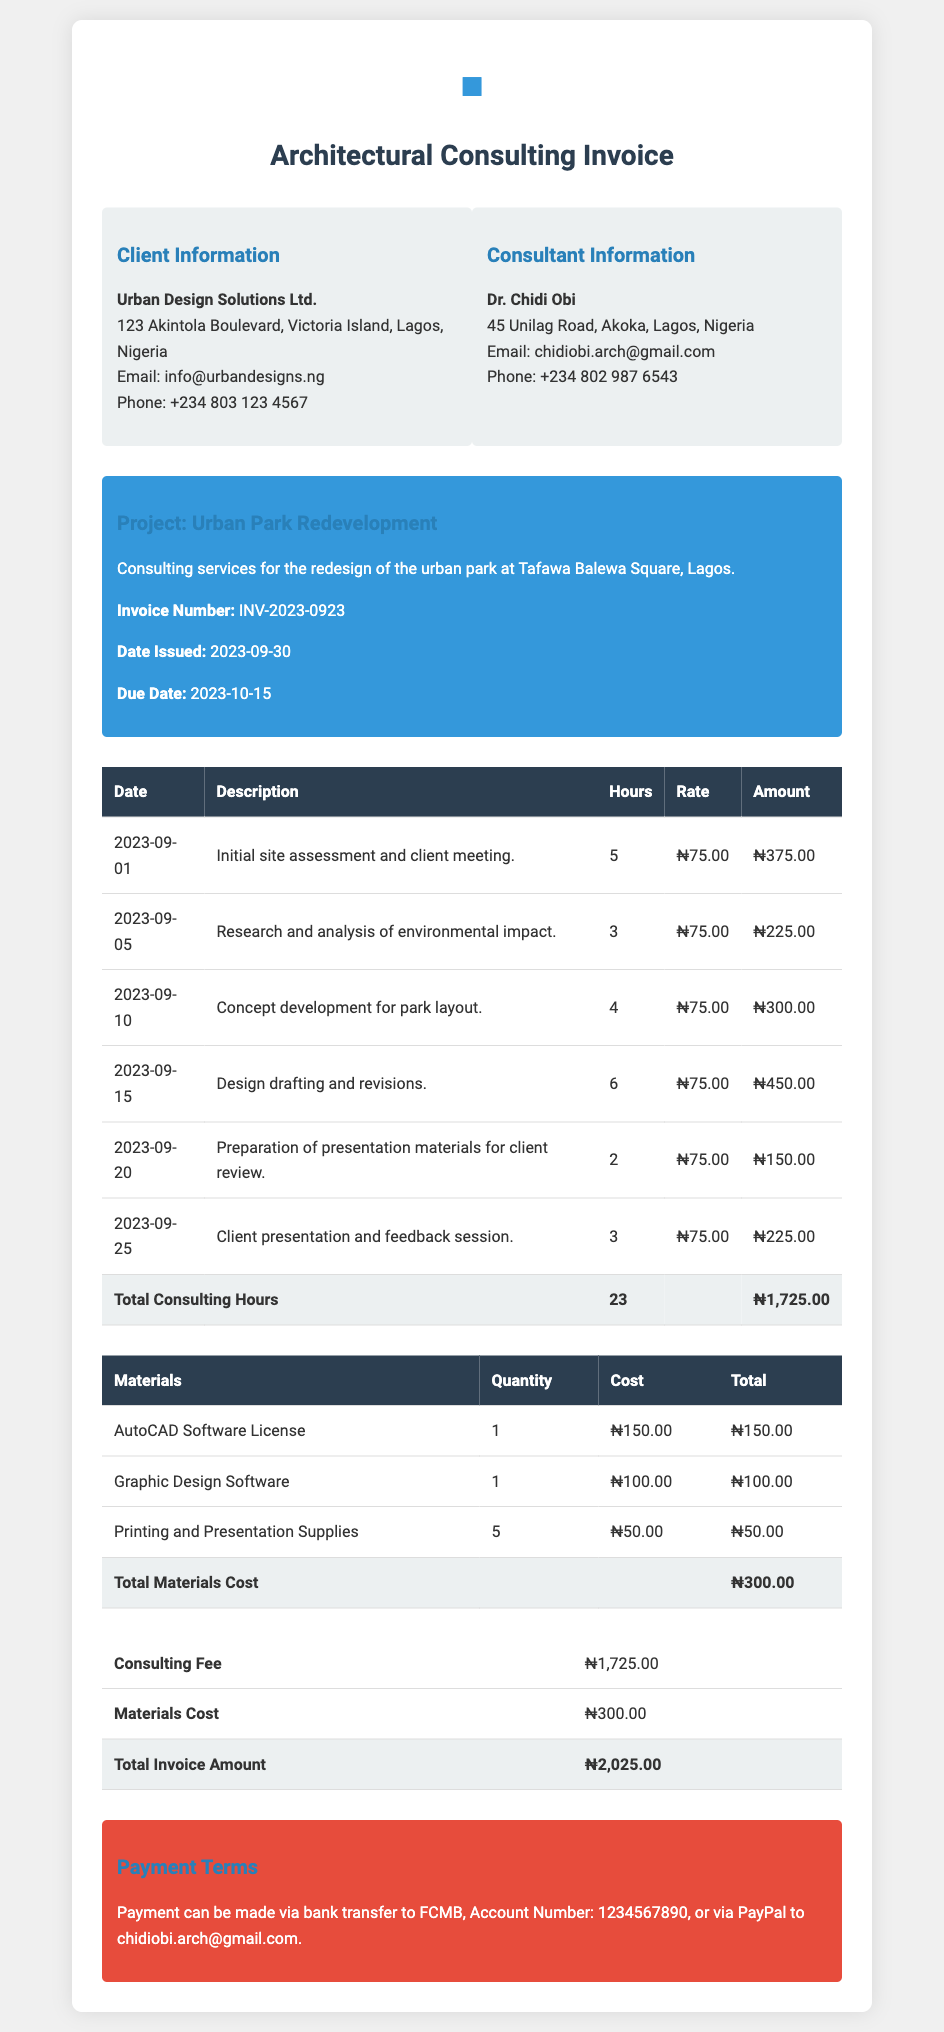What is the name of the client? The client is identified in the 'Client Information' section of the document as "Urban Design Solutions Ltd."
Answer: Urban Design Solutions Ltd What is the total number of consulting hours billed? The total consulting hours can be found in the summary row of the consulting hours table, which states "Total Consulting Hours".
Answer: 23 What is the date issued for the invoice? The 'Date Issued' is mentioned in the project details section of the document, stating the specific date the invoice was generated.
Answer: 2023-09-30 What is the total materials cost? The total materials cost is in the last row of the materials table, which summarizes the total financial outlay for materials used.
Answer: ₦300.00 Who is the consultant? The consultant's name appears in the 'Consultant Information' section of the document, indicating the individual providing the services.
Answer: Dr. Chidi Obi What is the invoice number? The invoice number can be found in the project details section under "Invoice Number".
Answer: INV-2023-0923 What is the payment due date? The due date for payment is stated in the project details section, indicating when the client is expected to pay the invoice.
Answer: 2023-10-15 How much is the consulting fee? The consulting fee is specified in the summary table of costs, showing the amount charged for the consulting services rendered.
Answer: ₦1,725.00 